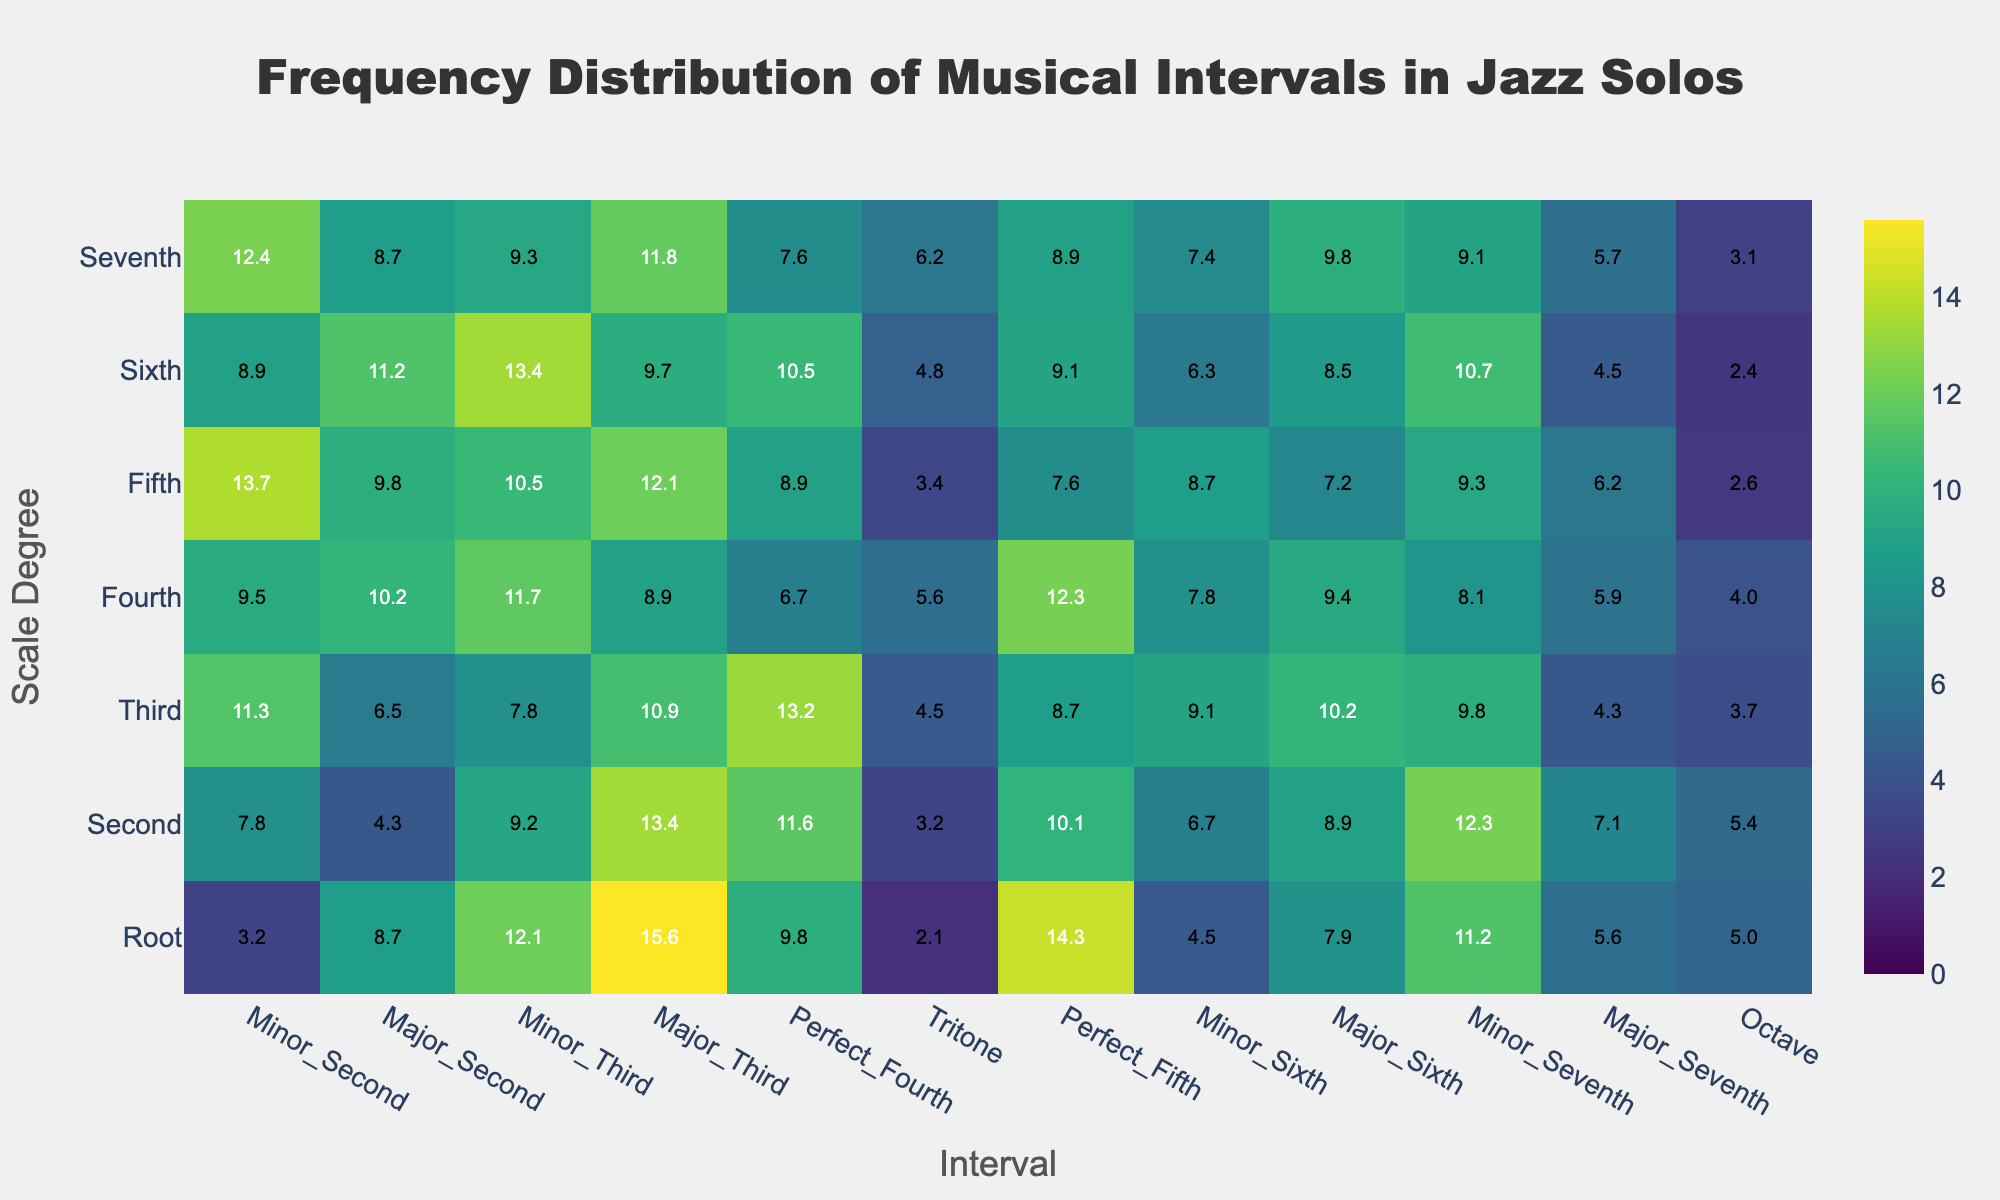What is the most frequent interval for the Root scale degree? To find the most frequent interval for the Root scale degree, look at the row labeled 'Root' and find the highest value. This value corresponds to the Major Third interval with a frequency of 15.6.
Answer: Major Third Which scale degree has the highest frequency of Minor Third intervals? Look for the highest value in the column labeled 'Minor_Third'. The highest value in this column is 13.4, which corresponds to both 'Sixth' and 'Second' scale degrees.
Answer: Sixth and Second What is the total frequency of Perfect Fifth intervals across all scale degrees? Sum the values in the column labeled 'Perfect_Fifth'. The values are 14.3, 10.1, 8.7, 12.3, 7.6, 9.1, and 8.9. Adding them together gives 71.0.
Answer: 71.0 Which scale degree has the lowest average frequency of all intervals? Calculate the average frequency for each scale degree by summing the values of each row and dividing by the number of intervals. Compare these averages. The 'Seventh' scale degree has the lowest average.
Answer: Seventh How does the frequency of the Major Seventh interval compare between the Root and Seventh scale degrees? Look at the values for the Major Seventh interval for both scale degrees. The frequency is 5.0 for the Root and 3.1 for the Seventh. 5.0 is greater than 3.1.
Answer: The frequency for Root is greater Which interval shows the largest variability in frequency across all scale degrees? To find the interval with the largest variability, calculate the range (maximum value - minimum value) for each interval. The 'Major_Third' interval has the largest variability with a range of 15.6.
Answer: Major Third What pattern do you observe in the frequency distribution of Tritone intervals? Look at the row patterns under 'Tritone'. The frequency values are generally low and do not have significant peaks or trends, staying mostly in the lower frequencies.
Answer: Mostly low frequency across all scale degrees What is the median frequency of the Major Second interval across all scale degrees? List the frequencies of the Major Second interval: 8.7, 4.3, 6.5, 10.2, 9.8, 11.2, 8.7. Ordering these values: 4.3, 6.5, 8.7, 8.7, 9.8, 10.2, 11.2, the median is 8.7.
Answer: 8.7 Compare the frequency of the Minor Seventh interval between the Third and Sixth scale degrees. Look at the Minor Seventh interval for both Third and Sixth scale degrees. The values are 9.8 and 10.7 respectively. 10.7 (Sixth) is greater than 9.8 (Third).
Answer: Sixth is greater How many times does the Major Sixth interval appear more than 8.0 in frequency across all scale degrees? Look for instances where the value in the 'Major_Sixth' column is greater than 8.0. The qualifying values are 8.9, 10.2, 8.5, 9.8. Therefore, it appears 4 times.
Answer: 4 